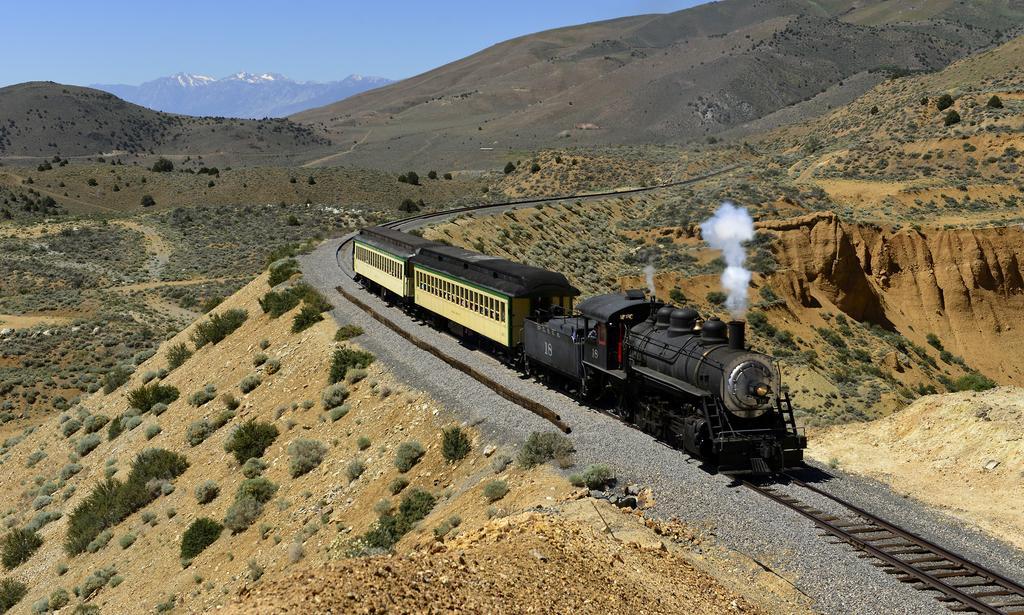Please provide a concise description of this image. In this picture we can see a train on the track, at the bottom there are some stones, in the background we can see some plants and hills, there is the sky at the top of the picture. 